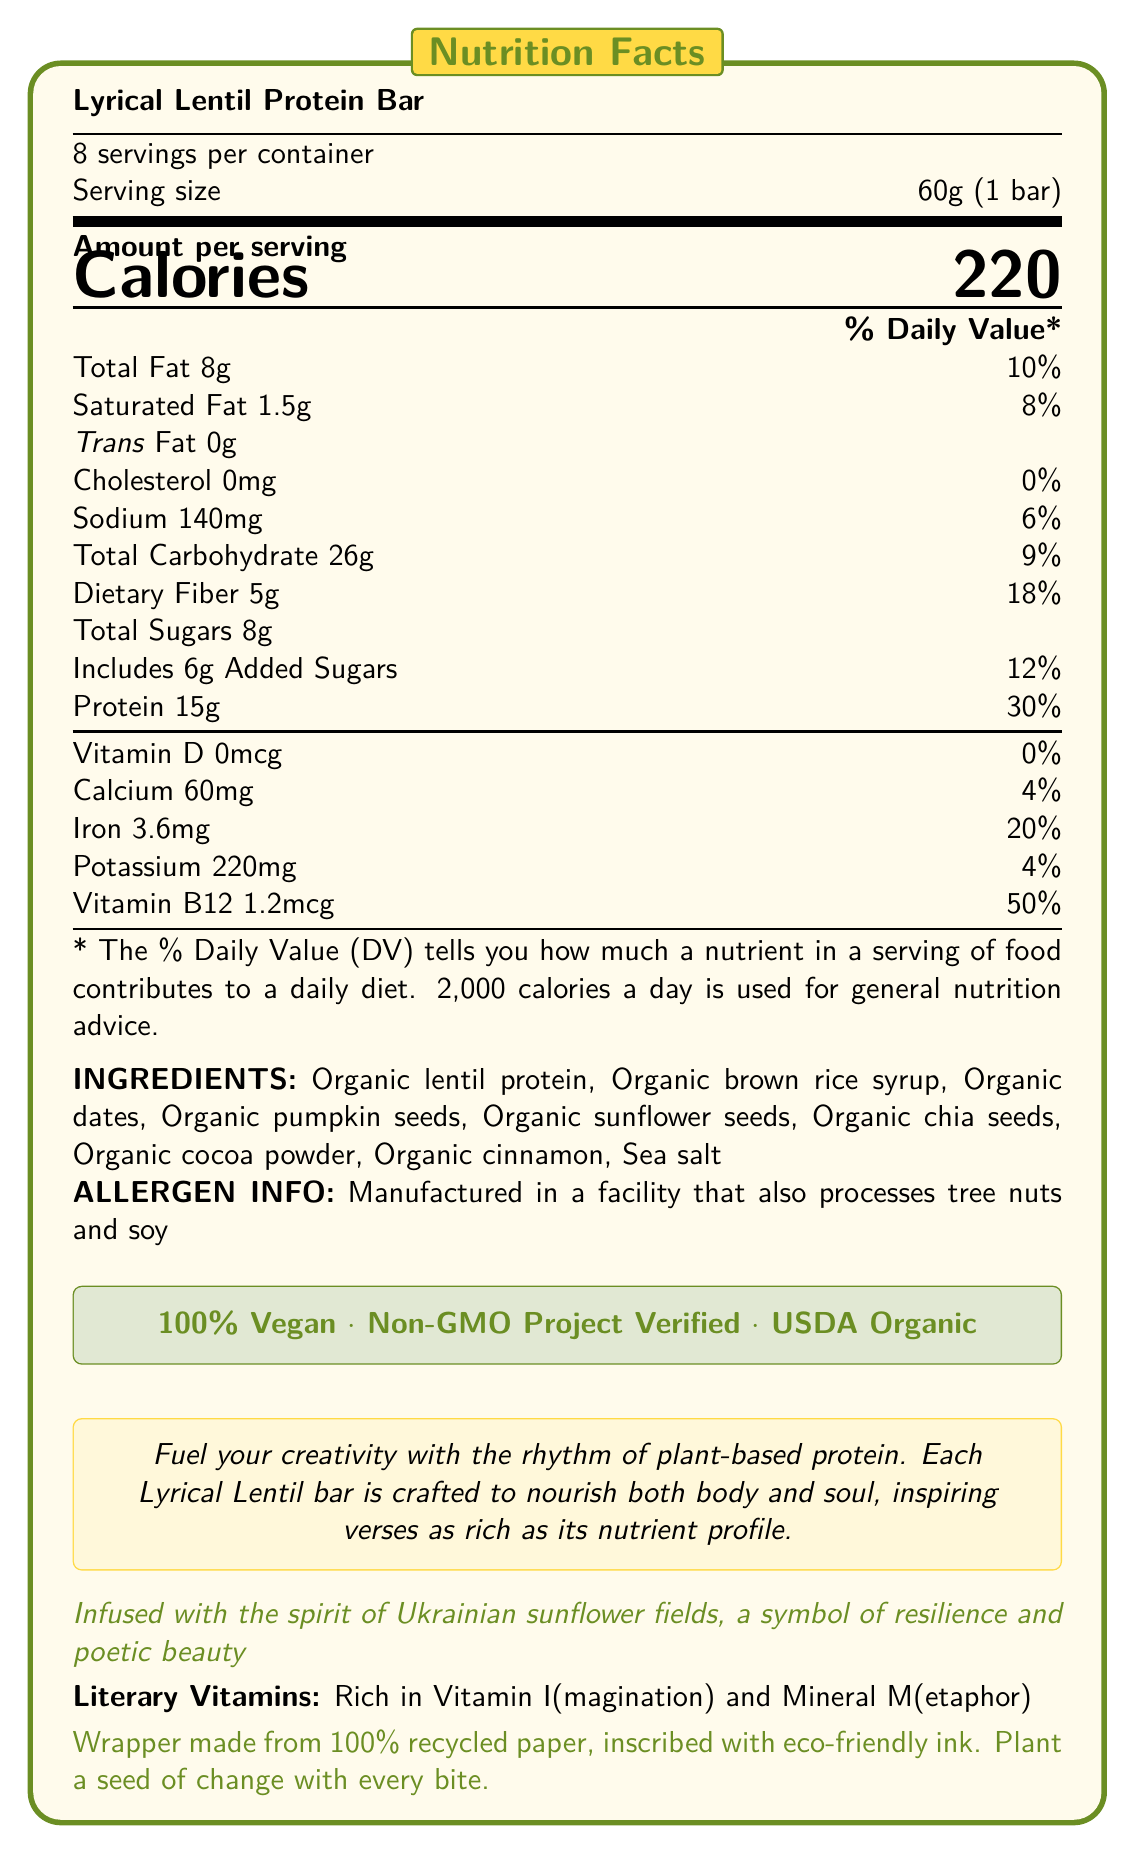How many servings are in one container of Lyrical Lentil Protein Bar? The document states that there are 8 servings per container.
Answer: 8 What is the serving size of the Lyrical Lentil Protein Bar? The serving size mentioned in the document is 60g or 1 bar.
Answer: 60g (1 bar) How many calories are there per serving? The document lists the amount per serving under the heading "Amount per serving", where calories are mentioned as 220.
Answer: 220 What percentage of Daily Value (% DV) does the protein content represent? The document shows that the protein content is 15g, which has a daily value of 30%.
Answer: 30% What is the main plant-based protein source in Lyrical Lentil Protein Bar? The ingredients section lists "Organic lentil protein" as the first ingredient, indicating it is the main plant-based protein source.
Answer: Organic lentil protein What percentage of the Daily Value of Vitamin B12 does one bar contain? A. 4% B. 20% C. 50% D. 18% According to the document, one bar provides 50% of the Daily Value of Vitamin B12.
Answer: C. 50% Which ingredient is not part of the Lyrical Lentil Protein Bar? A. Organic pumpkin seeds B. Organic sunflower seeds C. Organic chia seeds D. Organic almonds The ingredients section lists Organic lentil protein, Organic brown rice syrup, Organic dates, Organic pumpkin seeds, Organic sunflower seeds, Organic chia seeds, Organic cocoa powder, Organic cinnamon, and Sea salt. Organic almonds are not listed.
Answer: D. Organic almonds Is the protein bar vegan? The document states "100% Vegan" in a highlighted section.
Answer: Yes Describe the main idea of the document. The document provides detailed nutritional facts, ingredients, and claims regarding the bar's vegan and organic nature, along with a poetic marketing description and sustainability note.
Answer: The Lyrical Lentil Protein Bar is a vegan, non-GMO, and organic protein bar designed for health-conscious individuals. It contains plant-based protein sources, has specific nutritional content, and includes a poetic description emphasizing creativity and resilience. The product is packaged sustainably. How much dietary fiber does one serving contain? The document lists "Dietary Fiber 5g" under the total carbohydrate section.
Answer: 5g What unique claims are made about the Lyrical Lentil Protein Bar? The document includes these claims in a highlighted section, emphasizing the bar's certifications and attributes.
Answer: 100% Vegan, Non-GMO Project Verified, USDA Organic Does the nutrition facts section mention any allergens? The allergen information at the bottom of the document states that the product is "Manufactured in a facility that also processes tree nuts and soy".
Answer: Yes Can this document provide the exact production date of the Lyrical Lentil Protein Bar? The document focuses on the nutrition facts, ingredients, and certifications but does not provide detailed information about the production date or batch-related specifics.
Answer: Not enough information 